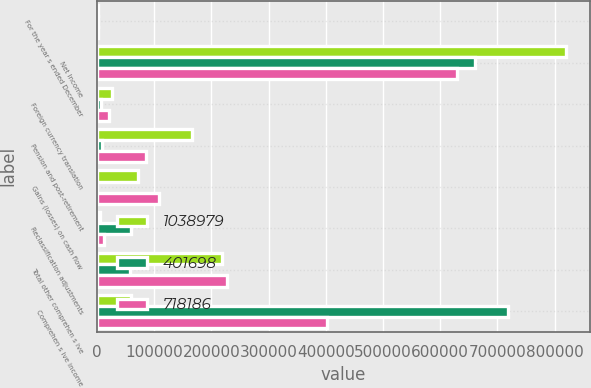<chart> <loc_0><loc_0><loc_500><loc_500><stacked_bar_chart><ecel><fcel>For the year s ended December<fcel>Net Income<fcel>Foreign currency translation<fcel>Pension and post-retirement<fcel>Gains (losses) on cash flow<fcel>Reclassification adjustments<fcel>Total other comprehen s ive<fcel>Comprehen s ive income<nl><fcel>1.03898e+06<fcel>2013<fcel>820470<fcel>26003<fcel>166403<fcel>72334<fcel>5775<fcel>218509<fcel>60043<nl><fcel>401698<fcel>2012<fcel>660931<fcel>7714<fcel>9634<fcel>868<fcel>60043<fcel>57255<fcel>718186<nl><fcel>718186<fcel>2011<fcel>628962<fcel>21213<fcel>85823<fcel>107713<fcel>12515<fcel>227264<fcel>401698<nl></chart> 